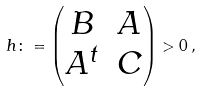<formula> <loc_0><loc_0><loc_500><loc_500>h \colon = \begin{pmatrix} B & A \\ A ^ { t } & C \end{pmatrix} > 0 \, ,</formula> 